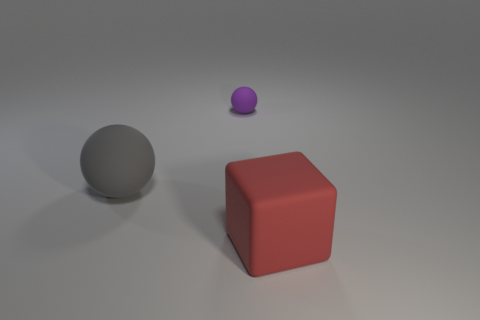Is there any other thing that has the same size as the purple ball?
Give a very brief answer. No. What number of other things are the same shape as the large gray rubber object?
Make the answer very short. 1. Is the number of small matte objects less than the number of objects?
Keep it short and to the point. Yes. There is a thing that is both right of the big gray object and left of the big red thing; what is its size?
Keep it short and to the point. Small. There is a object behind the large object behind the rubber object that is in front of the big gray matte sphere; what size is it?
Ensure brevity in your answer.  Small. What is the size of the purple matte object?
Your answer should be compact. Small. Is there a gray matte object right of the ball that is to the right of the matte sphere that is to the left of the tiny purple thing?
Make the answer very short. No. What number of big things are either red objects or blue shiny spheres?
Offer a terse response. 1. Is the size of the rubber thing that is in front of the gray thing the same as the big matte ball?
Make the answer very short. Yes. There is a big thing that is on the right side of the sphere on the right side of the big matte thing behind the big rubber block; what color is it?
Offer a very short reply. Red. 